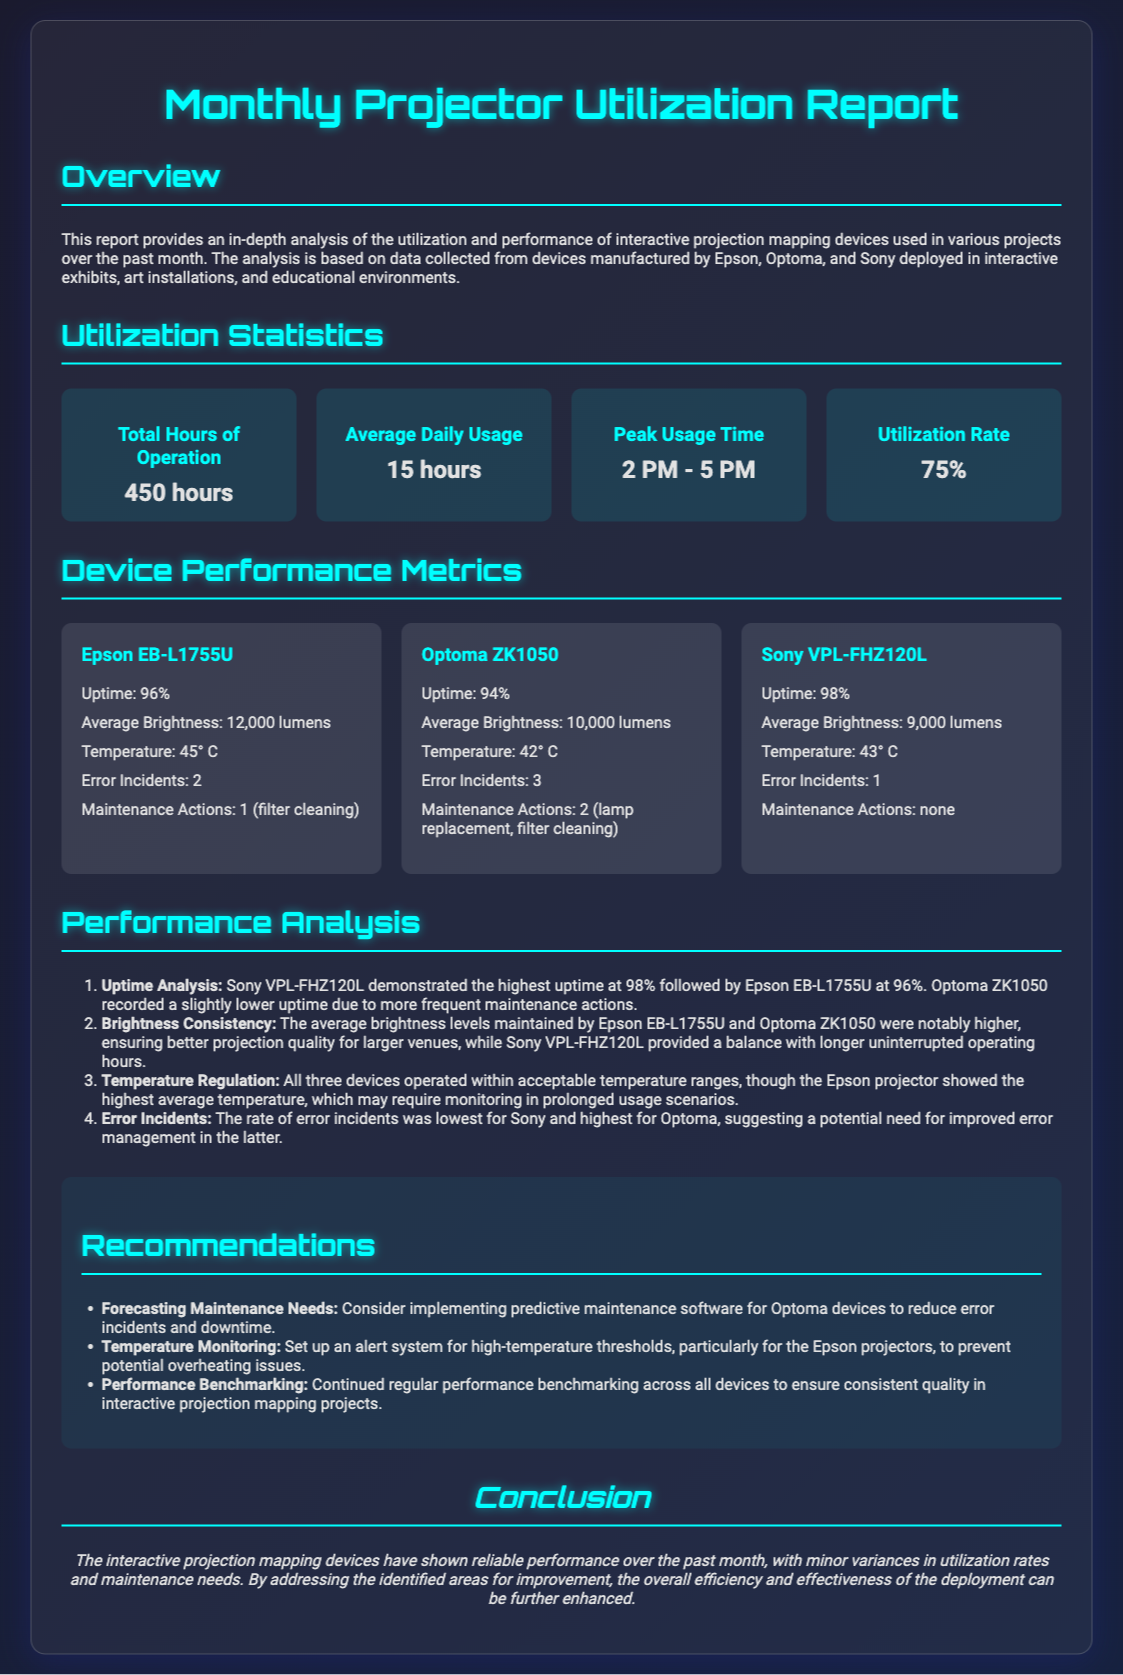What is the total hours of operation? The total hours of operation statistic is provided in the utilization statistics section of the document.
Answer: 450 hours What is the average daily usage of the projectors? This information can be found in the utilization statistics section, specifically listing the average daily usage statistic.
Answer: 15 hours Which projector has the highest uptime? The uptime data is mentioned in the device performance metrics section, comparing the uptime of each device.
Answer: Sony VPL-FHZ120L How many error incidents were reported for the Optoma ZK1050? The error incidents statistics for each device are listed in their respective sections, specifically for the Optoma device.
Answer: 3 What is the average brightness of the Epson EB-L1755U? The average brightness metric for each projector is detailed in the device performance metrics section, where the Epson's statistic is presented.
Answer: 12,000 lumens What is one recommendation given in the report? Recommendations are summarized in a section toward the end of the document, focusing on improvements for device performance.
Answer: Forecasting Maintenance Needs What is the peak usage time for the projectors? This statistic is found in the utilization statistics section and indicates the time frame with the highest usage.
Answer: 2 PM - 5 PM What maintenance action was taken for the Sony VPL-FHZ120L? The maintenance actions for each device are mentioned in the device performance metrics section, specifically for the Sony projector.
Answer: none What was the utilization rate for the projectors? This information is located in the utilization statistics section, providing insight into how frequently the projectors were used.
Answer: 75% 